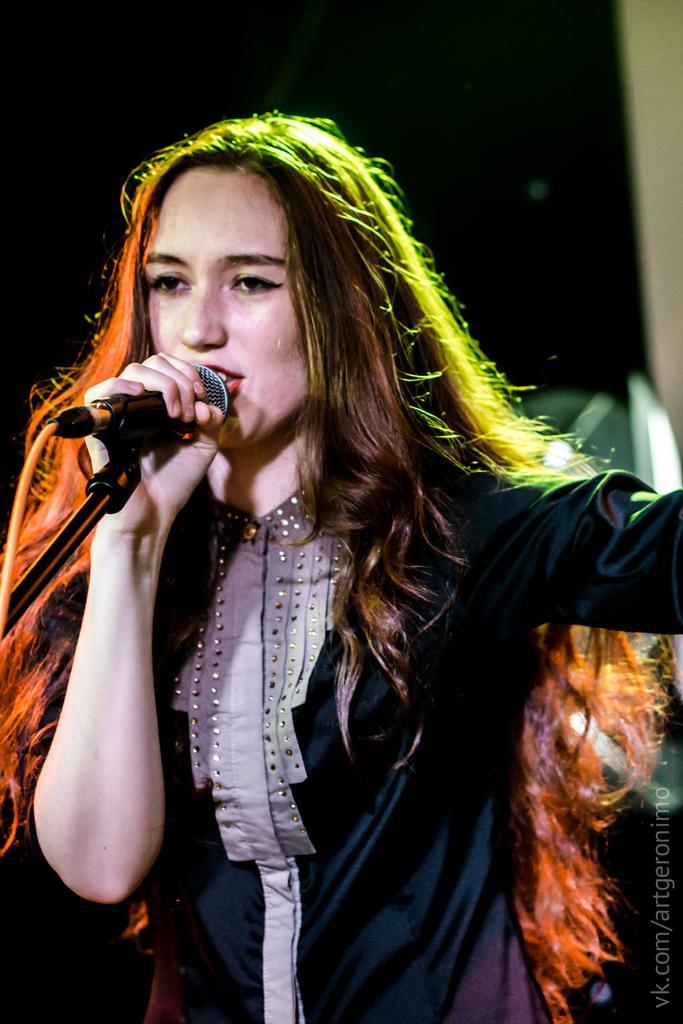Can you describe this image briefly? In this picture we can see one woman holding a microphone and speaking something as we can see her mouth. 